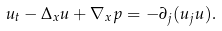Convert formula to latex. <formula><loc_0><loc_0><loc_500><loc_500>u _ { t } - \Delta _ { x } u + \nabla _ { x } p = - \partial _ { j } ( u _ { j } u ) .</formula> 